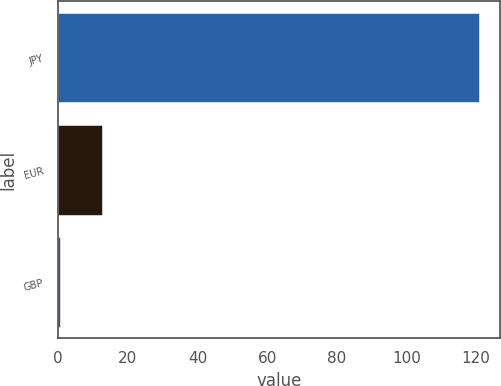<chart> <loc_0><loc_0><loc_500><loc_500><bar_chart><fcel>JPY<fcel>EUR<fcel>GBP<nl><fcel>120.82<fcel>12.67<fcel>0.65<nl></chart> 